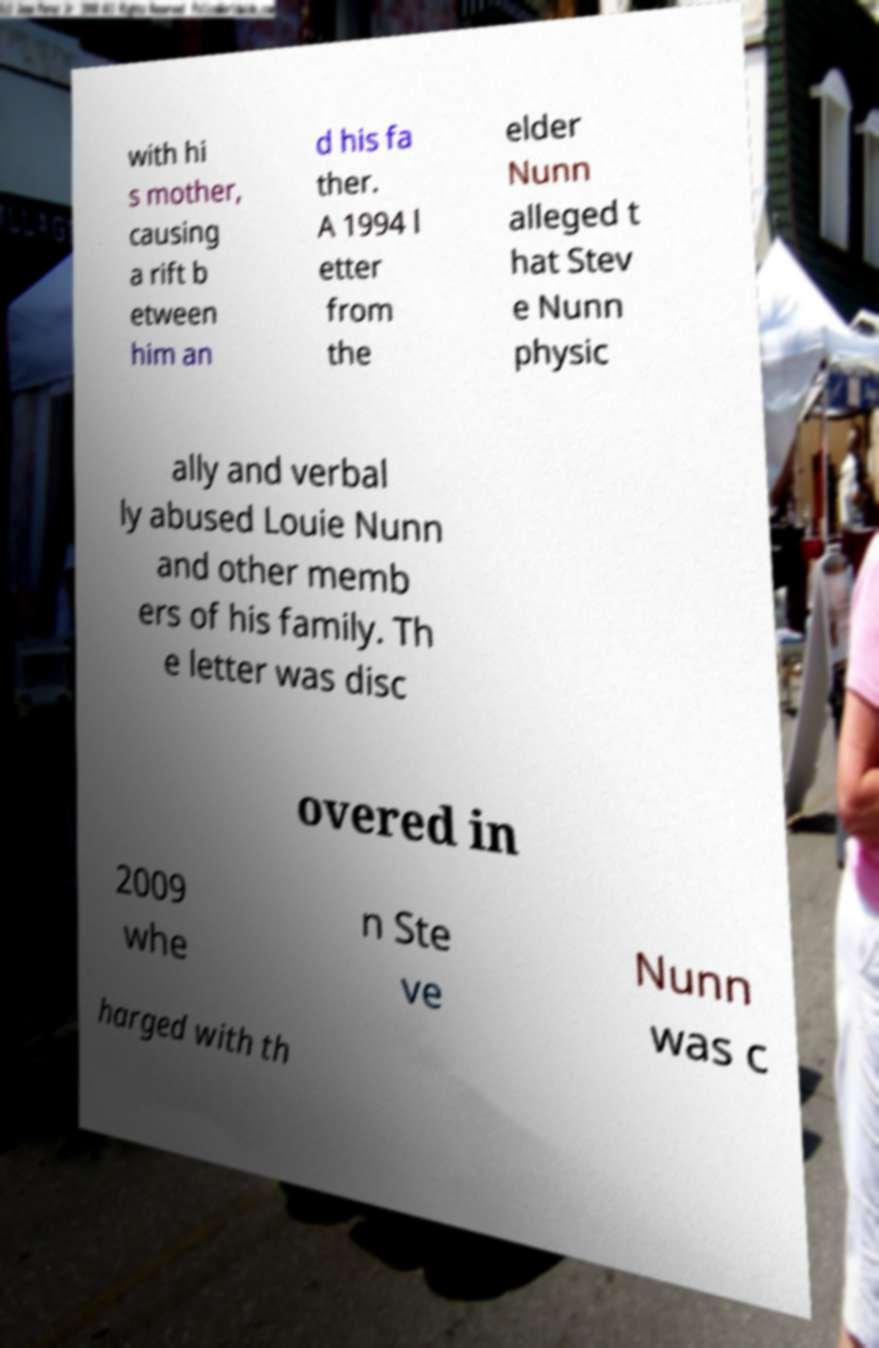Can you read and provide the text displayed in the image?This photo seems to have some interesting text. Can you extract and type it out for me? with hi s mother, causing a rift b etween him an d his fa ther. A 1994 l etter from the elder Nunn alleged t hat Stev e Nunn physic ally and verbal ly abused Louie Nunn and other memb ers of his family. Th e letter was disc overed in 2009 whe n Ste ve Nunn was c harged with th 